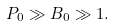Convert formula to latex. <formula><loc_0><loc_0><loc_500><loc_500>P _ { 0 } \gg B _ { 0 } \gg 1 .</formula> 